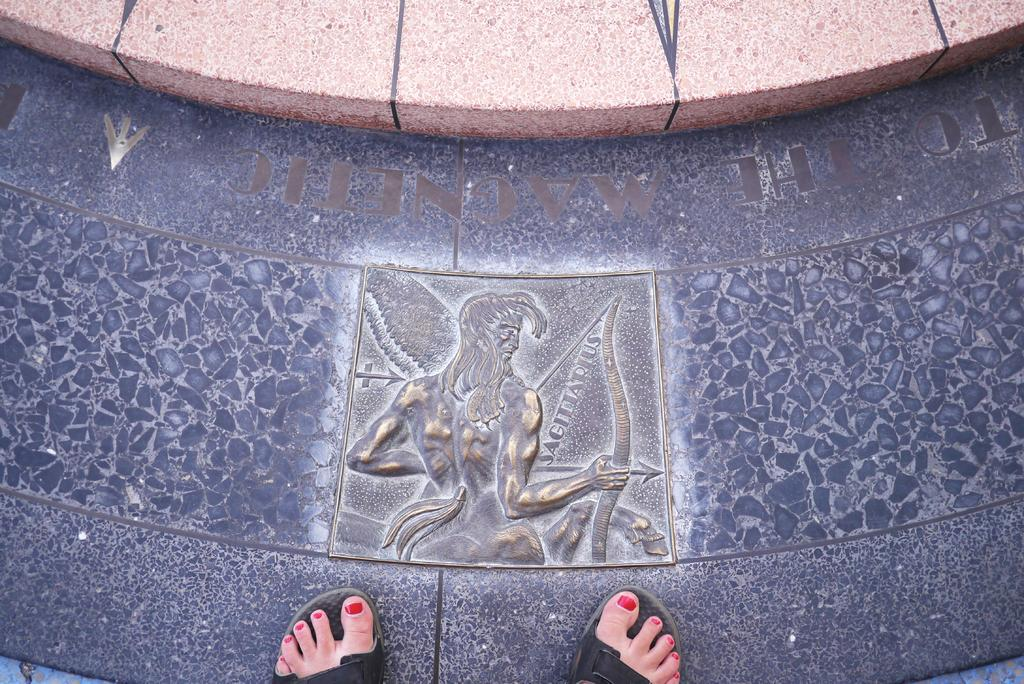Who is present in the image? There is a person in the image. What is the person standing in front of? The person is standing in front of carving art. What is the spark level of the carving art in the image? There is no mention of a spark or spark level in the image, as it features a person standing in front of carving art. 